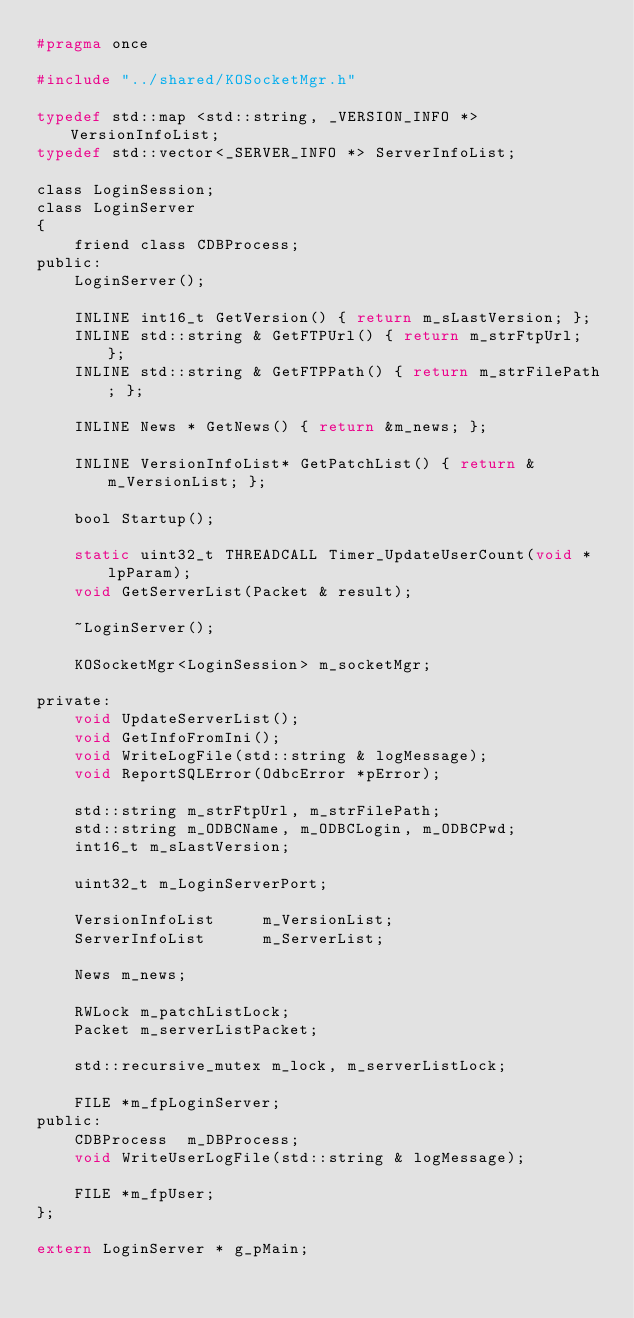<code> <loc_0><loc_0><loc_500><loc_500><_C_>#pragma once

#include "../shared/KOSocketMgr.h"

typedef std::map <std::string, _VERSION_INFO *> VersionInfoList;
typedef std::vector<_SERVER_INFO *>	ServerInfoList;

class LoginSession;
class LoginServer
{
	friend class CDBProcess;
public:
	LoginServer();

	INLINE int16_t GetVersion() { return m_sLastVersion; };
	INLINE std::string & GetFTPUrl() { return m_strFtpUrl; };
	INLINE std::string & GetFTPPath() { return m_strFilePath; };

	INLINE News * GetNews() { return &m_news; };

	INLINE VersionInfoList* GetPatchList() { return &m_VersionList; };

	bool Startup();

	static uint32_t THREADCALL Timer_UpdateUserCount(void * lpParam);
	void GetServerList(Packet & result);

	~LoginServer();

	KOSocketMgr<LoginSession> m_socketMgr;

private:
	void UpdateServerList();
	void GetInfoFromIni();
	void WriteLogFile(std::string & logMessage);
	void ReportSQLError(OdbcError *pError);

	std::string m_strFtpUrl, m_strFilePath;
	std::string m_ODBCName, m_ODBCLogin, m_ODBCPwd;
	int16_t	m_sLastVersion;

	uint32_t m_LoginServerPort;

	VersionInfoList		m_VersionList;
	ServerInfoList		m_ServerList;

	News m_news;

	RWLock m_patchListLock;
	Packet m_serverListPacket;

	std::recursive_mutex m_lock, m_serverListLock;

	FILE *m_fpLoginServer;
public:
	CDBProcess	m_DBProcess;
	void WriteUserLogFile(std::string & logMessage);

	FILE *m_fpUser;
};

extern LoginServer * g_pMain;
</code> 